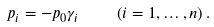<formula> <loc_0><loc_0><loc_500><loc_500>p _ { i } = - p _ { 0 } \gamma _ { i } \quad \left ( i = 1 , \dots , n \right ) .</formula> 